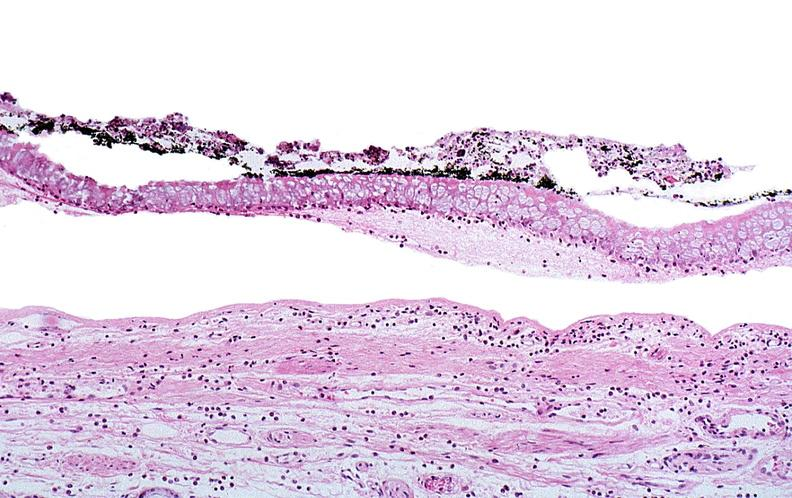does linear fracture in occiput show thermal burned skin?
Answer the question using a single word or phrase. No 